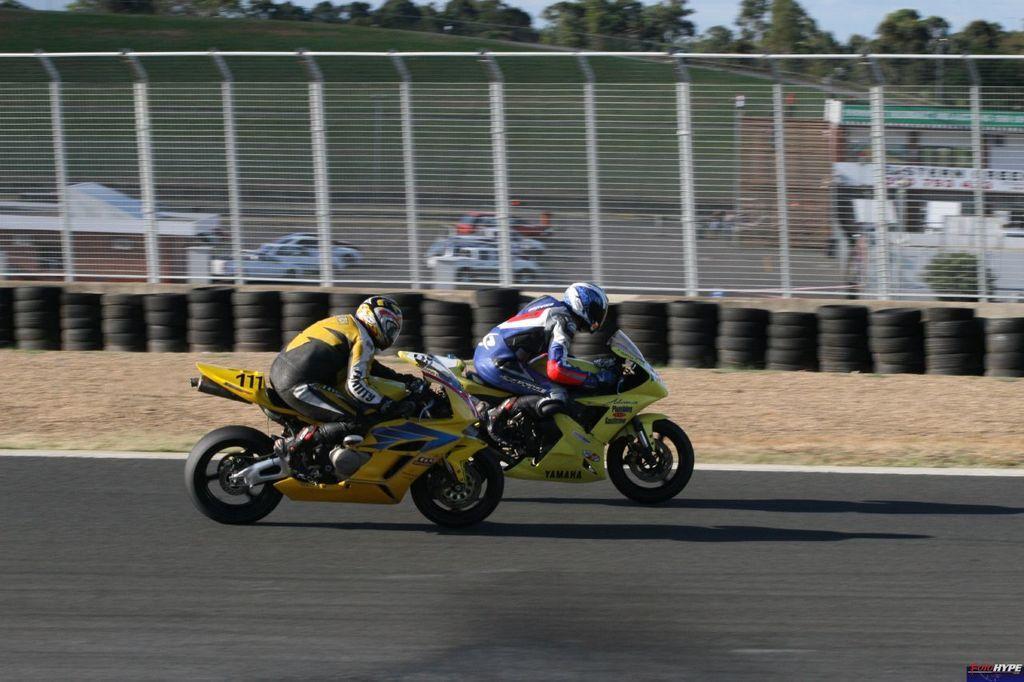Describe this image in one or two sentences. In this picture we can see two people wore helmets and riding motorbikes on the road, fence, tyres, cars, trees, building and some objects and in the background we can see the sky. 